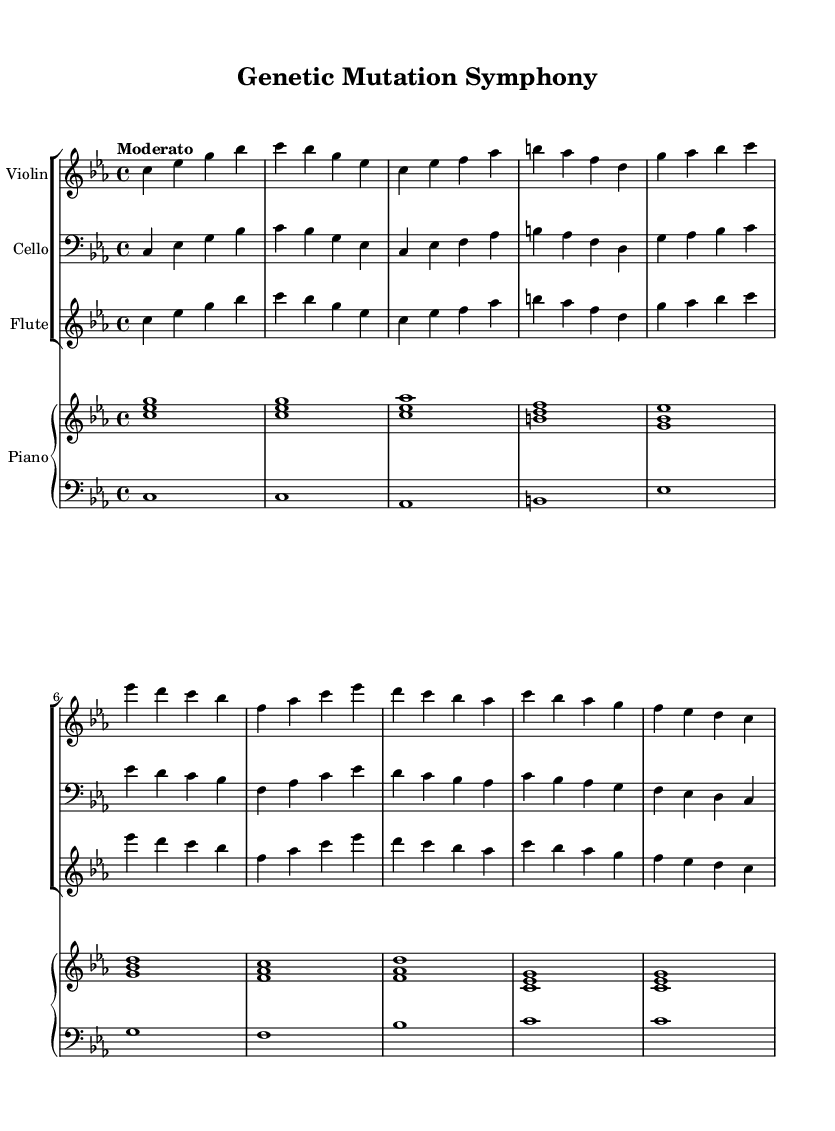What is the key signature of this music? The key signature is C minor, which has three flats (B♭, E♭, A♭) indicating that it is in a minor key.
Answer: C minor What is the time signature of this music? The time signature is 4/4, which means there are four beats in a measure and the quarter note gets one beat. This can be identified at the beginning of the score.
Answer: 4/4 What is the tempo marking of this piece? The tempo marking indicates "Moderato," which generally suggests a moderate pace. It is given at the beginning of the score.
Answer: Moderato How many main sections are there in this symphony? The symphony consists of five sections: Introduction, Mutation Event, Phenotypic Change, Adaptation, and Conclusion, each identifiable by the thematic material presented.
Answer: Five Which instrument is playing the highest pitch in the first section? The violin is playing the highest pitch in the first section, as it is typically tuned higher than the cello and plays in the upper register throughout.
Answer: Violin What musical event marks the transition to the "Phenotypic Change" section? The transition to the "Phenotypic Change" section is marked by a shift in the melodic line and harmony, indicating a change in musical theme that corresponds to the representation of genetic mutations.
Answer: Shift in melody and harmony What does the piano play during the "Mutation Event" section? During the "Mutation Event" section, the piano plays specific chords indicating the significant mutation occurrence, which contributes to the overall musical narrative of the piece.
Answer: Chords indicating mutation 